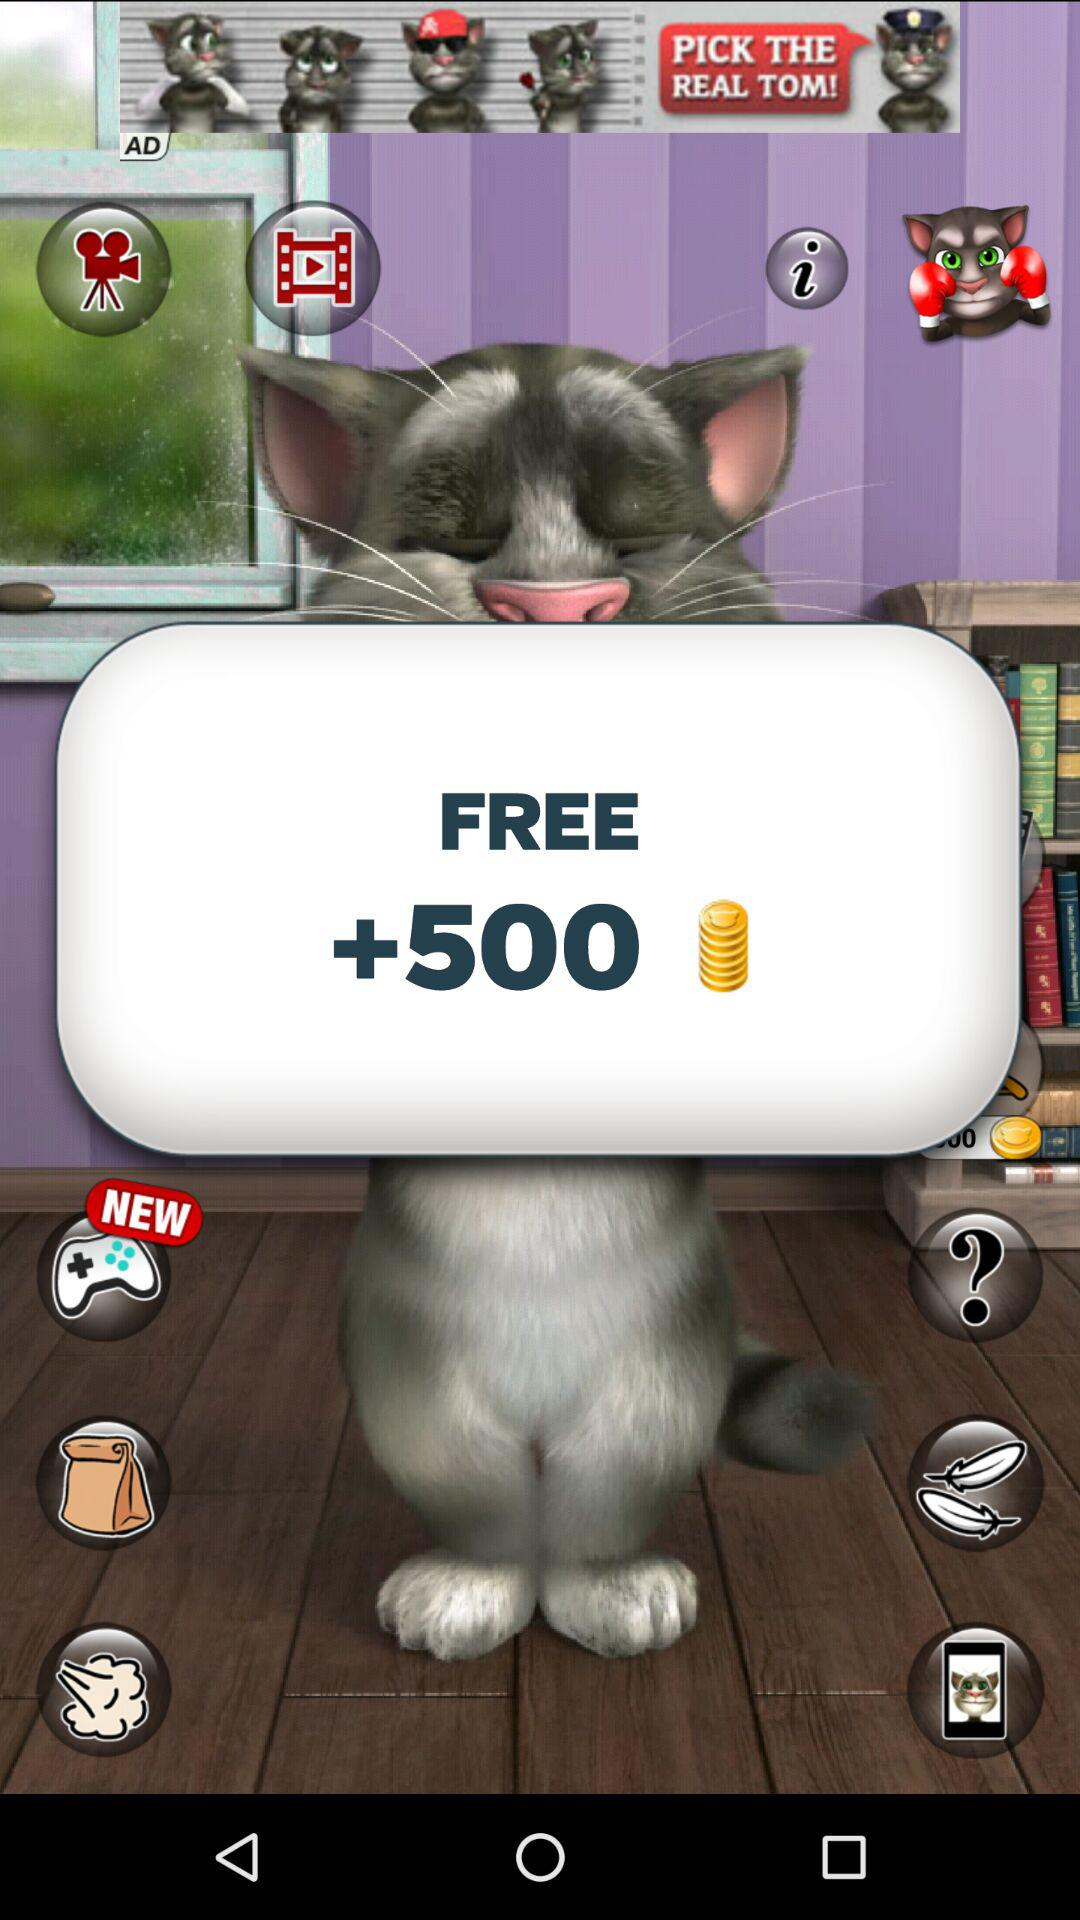What is the count of the free coin? The count is 500. 